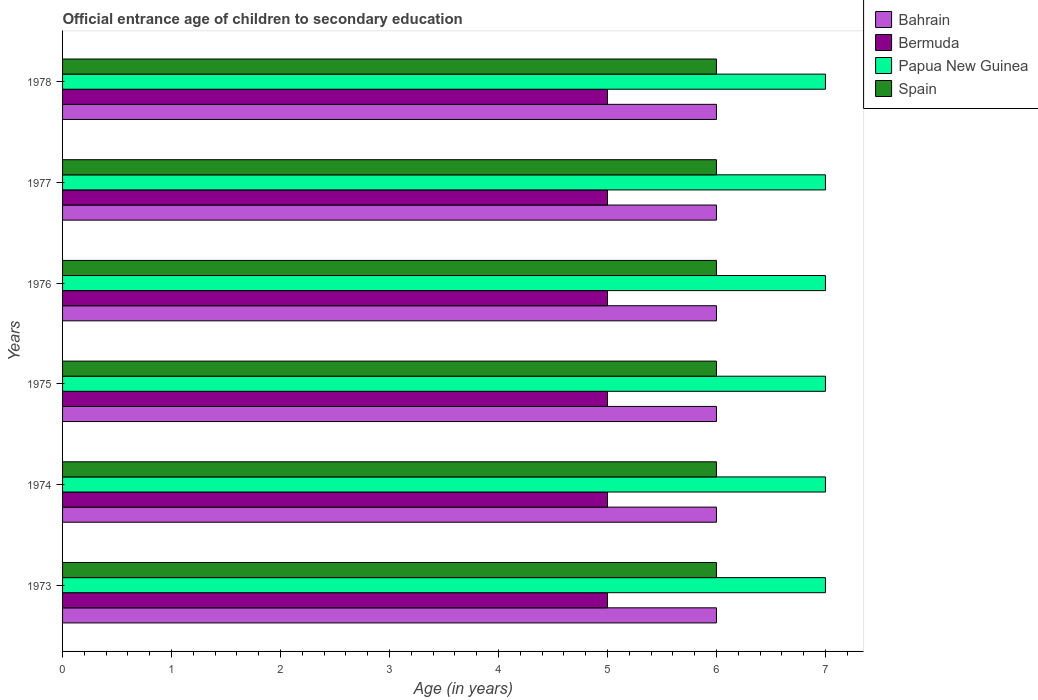How many groups of bars are there?
Make the answer very short. 6. Are the number of bars per tick equal to the number of legend labels?
Keep it short and to the point. Yes. How many bars are there on the 2nd tick from the bottom?
Offer a very short reply. 4. What is the label of the 5th group of bars from the top?
Offer a terse response. 1974. What is the secondary school starting age of children in Bermuda in 1975?
Provide a succinct answer. 5. Across all years, what is the maximum secondary school starting age of children in Papua New Guinea?
Your response must be concise. 7. Across all years, what is the minimum secondary school starting age of children in Papua New Guinea?
Your response must be concise. 7. What is the total secondary school starting age of children in Bahrain in the graph?
Your answer should be very brief. 36. What is the difference between the secondary school starting age of children in Bermuda in 1978 and the secondary school starting age of children in Papua New Guinea in 1976?
Your answer should be very brief. -2. In the year 1978, what is the difference between the secondary school starting age of children in Papua New Guinea and secondary school starting age of children in Spain?
Your answer should be very brief. 1. What is the ratio of the secondary school starting age of children in Bahrain in 1973 to that in 1975?
Your answer should be very brief. 1. Is the secondary school starting age of children in Bahrain in 1975 less than that in 1976?
Offer a terse response. No. In how many years, is the secondary school starting age of children in Papua New Guinea greater than the average secondary school starting age of children in Papua New Guinea taken over all years?
Give a very brief answer. 0. What does the 4th bar from the top in 1973 represents?
Your response must be concise. Bahrain. What does the 3rd bar from the bottom in 1977 represents?
Provide a succinct answer. Papua New Guinea. How many bars are there?
Your answer should be compact. 24. How many years are there in the graph?
Keep it short and to the point. 6. Does the graph contain grids?
Offer a very short reply. No. How are the legend labels stacked?
Your answer should be compact. Vertical. What is the title of the graph?
Keep it short and to the point. Official entrance age of children to secondary education. Does "Andorra" appear as one of the legend labels in the graph?
Make the answer very short. No. What is the label or title of the X-axis?
Keep it short and to the point. Age (in years). What is the Age (in years) of Bermuda in 1973?
Give a very brief answer. 5. What is the Age (in years) of Spain in 1974?
Your answer should be very brief. 6. What is the Age (in years) in Bahrain in 1975?
Provide a succinct answer. 6. What is the Age (in years) in Bermuda in 1975?
Offer a terse response. 5. What is the Age (in years) in Papua New Guinea in 1975?
Make the answer very short. 7. What is the Age (in years) of Bahrain in 1976?
Give a very brief answer. 6. What is the Age (in years) in Bermuda in 1976?
Keep it short and to the point. 5. What is the Age (in years) in Spain in 1977?
Keep it short and to the point. 6. What is the Age (in years) in Bahrain in 1978?
Ensure brevity in your answer.  6. What is the Age (in years) in Bermuda in 1978?
Offer a very short reply. 5. What is the Age (in years) in Spain in 1978?
Offer a terse response. 6. Across all years, what is the maximum Age (in years) of Papua New Guinea?
Your answer should be compact. 7. Across all years, what is the maximum Age (in years) in Spain?
Offer a very short reply. 6. Across all years, what is the minimum Age (in years) of Bahrain?
Give a very brief answer. 6. What is the total Age (in years) of Spain in the graph?
Provide a succinct answer. 36. What is the difference between the Age (in years) of Bahrain in 1973 and that in 1974?
Give a very brief answer. 0. What is the difference between the Age (in years) in Papua New Guinea in 1973 and that in 1974?
Offer a terse response. 0. What is the difference between the Age (in years) in Bahrain in 1973 and that in 1975?
Your answer should be compact. 0. What is the difference between the Age (in years) of Bermuda in 1973 and that in 1975?
Your answer should be compact. 0. What is the difference between the Age (in years) in Spain in 1973 and that in 1975?
Provide a short and direct response. 0. What is the difference between the Age (in years) in Bahrain in 1973 and that in 1976?
Provide a succinct answer. 0. What is the difference between the Age (in years) of Papua New Guinea in 1973 and that in 1976?
Provide a succinct answer. 0. What is the difference between the Age (in years) of Spain in 1973 and that in 1976?
Make the answer very short. 0. What is the difference between the Age (in years) of Bahrain in 1973 and that in 1977?
Provide a succinct answer. 0. What is the difference between the Age (in years) in Papua New Guinea in 1973 and that in 1978?
Make the answer very short. 0. What is the difference between the Age (in years) in Spain in 1973 and that in 1978?
Provide a short and direct response. 0. What is the difference between the Age (in years) in Bahrain in 1974 and that in 1975?
Your answer should be very brief. 0. What is the difference between the Age (in years) of Papua New Guinea in 1974 and that in 1975?
Make the answer very short. 0. What is the difference between the Age (in years) of Bahrain in 1974 and that in 1976?
Offer a terse response. 0. What is the difference between the Age (in years) of Bermuda in 1974 and that in 1976?
Your response must be concise. 0. What is the difference between the Age (in years) in Papua New Guinea in 1974 and that in 1976?
Keep it short and to the point. 0. What is the difference between the Age (in years) of Spain in 1974 and that in 1976?
Your response must be concise. 0. What is the difference between the Age (in years) in Bahrain in 1974 and that in 1977?
Provide a short and direct response. 0. What is the difference between the Age (in years) of Bermuda in 1974 and that in 1977?
Make the answer very short. 0. What is the difference between the Age (in years) of Spain in 1974 and that in 1978?
Keep it short and to the point. 0. What is the difference between the Age (in years) in Bahrain in 1975 and that in 1976?
Your answer should be very brief. 0. What is the difference between the Age (in years) in Bermuda in 1975 and that in 1976?
Your answer should be compact. 0. What is the difference between the Age (in years) in Spain in 1975 and that in 1976?
Your answer should be compact. 0. What is the difference between the Age (in years) in Bahrain in 1975 and that in 1977?
Ensure brevity in your answer.  0. What is the difference between the Age (in years) in Bermuda in 1975 and that in 1977?
Your answer should be very brief. 0. What is the difference between the Age (in years) of Papua New Guinea in 1975 and that in 1977?
Make the answer very short. 0. What is the difference between the Age (in years) in Spain in 1975 and that in 1977?
Provide a succinct answer. 0. What is the difference between the Age (in years) of Bahrain in 1975 and that in 1978?
Give a very brief answer. 0. What is the difference between the Age (in years) in Bermuda in 1975 and that in 1978?
Provide a succinct answer. 0. What is the difference between the Age (in years) in Papua New Guinea in 1975 and that in 1978?
Your answer should be compact. 0. What is the difference between the Age (in years) in Spain in 1976 and that in 1977?
Offer a terse response. 0. What is the difference between the Age (in years) of Bahrain in 1976 and that in 1978?
Offer a terse response. 0. What is the difference between the Age (in years) of Papua New Guinea in 1976 and that in 1978?
Make the answer very short. 0. What is the difference between the Age (in years) in Bahrain in 1977 and that in 1978?
Provide a succinct answer. 0. What is the difference between the Age (in years) in Papua New Guinea in 1977 and that in 1978?
Your answer should be very brief. 0. What is the difference between the Age (in years) in Spain in 1977 and that in 1978?
Ensure brevity in your answer.  0. What is the difference between the Age (in years) of Bahrain in 1973 and the Age (in years) of Bermuda in 1974?
Your answer should be compact. 1. What is the difference between the Age (in years) in Papua New Guinea in 1973 and the Age (in years) in Spain in 1974?
Provide a succinct answer. 1. What is the difference between the Age (in years) of Bahrain in 1973 and the Age (in years) of Papua New Guinea in 1975?
Give a very brief answer. -1. What is the difference between the Age (in years) of Bahrain in 1973 and the Age (in years) of Spain in 1975?
Your answer should be very brief. 0. What is the difference between the Age (in years) of Bermuda in 1973 and the Age (in years) of Spain in 1975?
Keep it short and to the point. -1. What is the difference between the Age (in years) of Bahrain in 1973 and the Age (in years) of Bermuda in 1976?
Your answer should be compact. 1. What is the difference between the Age (in years) in Bermuda in 1973 and the Age (in years) in Spain in 1976?
Ensure brevity in your answer.  -1. What is the difference between the Age (in years) of Papua New Guinea in 1973 and the Age (in years) of Spain in 1976?
Offer a very short reply. 1. What is the difference between the Age (in years) of Bahrain in 1973 and the Age (in years) of Papua New Guinea in 1977?
Your response must be concise. -1. What is the difference between the Age (in years) in Bahrain in 1973 and the Age (in years) in Spain in 1977?
Ensure brevity in your answer.  0. What is the difference between the Age (in years) in Bermuda in 1973 and the Age (in years) in Spain in 1977?
Provide a succinct answer. -1. What is the difference between the Age (in years) in Bahrain in 1973 and the Age (in years) in Bermuda in 1978?
Offer a very short reply. 1. What is the difference between the Age (in years) of Bermuda in 1973 and the Age (in years) of Papua New Guinea in 1978?
Make the answer very short. -2. What is the difference between the Age (in years) in Bahrain in 1974 and the Age (in years) in Bermuda in 1975?
Make the answer very short. 1. What is the difference between the Age (in years) in Bahrain in 1974 and the Age (in years) in Papua New Guinea in 1975?
Ensure brevity in your answer.  -1. What is the difference between the Age (in years) of Bahrain in 1974 and the Age (in years) of Spain in 1975?
Provide a short and direct response. 0. What is the difference between the Age (in years) of Bermuda in 1974 and the Age (in years) of Papua New Guinea in 1975?
Make the answer very short. -2. What is the difference between the Age (in years) of Papua New Guinea in 1974 and the Age (in years) of Spain in 1975?
Your response must be concise. 1. What is the difference between the Age (in years) in Bahrain in 1974 and the Age (in years) in Bermuda in 1976?
Your answer should be very brief. 1. What is the difference between the Age (in years) of Bahrain in 1974 and the Age (in years) of Spain in 1976?
Your answer should be compact. 0. What is the difference between the Age (in years) of Bermuda in 1974 and the Age (in years) of Spain in 1976?
Give a very brief answer. -1. What is the difference between the Age (in years) in Papua New Guinea in 1974 and the Age (in years) in Spain in 1976?
Give a very brief answer. 1. What is the difference between the Age (in years) of Bahrain in 1974 and the Age (in years) of Papua New Guinea in 1977?
Offer a terse response. -1. What is the difference between the Age (in years) of Bahrain in 1974 and the Age (in years) of Spain in 1977?
Offer a terse response. 0. What is the difference between the Age (in years) in Papua New Guinea in 1974 and the Age (in years) in Spain in 1977?
Provide a short and direct response. 1. What is the difference between the Age (in years) of Bermuda in 1974 and the Age (in years) of Papua New Guinea in 1978?
Give a very brief answer. -2. What is the difference between the Age (in years) in Bahrain in 1975 and the Age (in years) in Papua New Guinea in 1976?
Make the answer very short. -1. What is the difference between the Age (in years) of Bermuda in 1975 and the Age (in years) of Papua New Guinea in 1976?
Offer a terse response. -2. What is the difference between the Age (in years) in Papua New Guinea in 1975 and the Age (in years) in Spain in 1976?
Offer a very short reply. 1. What is the difference between the Age (in years) of Bahrain in 1975 and the Age (in years) of Papua New Guinea in 1977?
Make the answer very short. -1. What is the difference between the Age (in years) of Bahrain in 1975 and the Age (in years) of Spain in 1978?
Make the answer very short. 0. What is the difference between the Age (in years) of Papua New Guinea in 1975 and the Age (in years) of Spain in 1978?
Provide a succinct answer. 1. What is the difference between the Age (in years) in Bahrain in 1976 and the Age (in years) in Papua New Guinea in 1977?
Offer a very short reply. -1. What is the difference between the Age (in years) of Bermuda in 1976 and the Age (in years) of Spain in 1977?
Offer a very short reply. -1. What is the difference between the Age (in years) in Bahrain in 1976 and the Age (in years) in Papua New Guinea in 1978?
Keep it short and to the point. -1. What is the difference between the Age (in years) in Bahrain in 1976 and the Age (in years) in Spain in 1978?
Ensure brevity in your answer.  0. What is the difference between the Age (in years) of Bermuda in 1976 and the Age (in years) of Papua New Guinea in 1978?
Give a very brief answer. -2. What is the difference between the Age (in years) in Papua New Guinea in 1976 and the Age (in years) in Spain in 1978?
Offer a very short reply. 1. What is the difference between the Age (in years) in Bahrain in 1977 and the Age (in years) in Bermuda in 1978?
Your answer should be very brief. 1. What is the difference between the Age (in years) of Bahrain in 1977 and the Age (in years) of Papua New Guinea in 1978?
Your answer should be very brief. -1. What is the difference between the Age (in years) of Bermuda in 1977 and the Age (in years) of Papua New Guinea in 1978?
Offer a terse response. -2. What is the difference between the Age (in years) in Papua New Guinea in 1977 and the Age (in years) in Spain in 1978?
Offer a very short reply. 1. What is the average Age (in years) of Bahrain per year?
Offer a very short reply. 6. What is the average Age (in years) of Bermuda per year?
Provide a short and direct response. 5. What is the average Age (in years) in Papua New Guinea per year?
Provide a succinct answer. 7. What is the average Age (in years) of Spain per year?
Give a very brief answer. 6. In the year 1973, what is the difference between the Age (in years) of Bahrain and Age (in years) of Bermuda?
Give a very brief answer. 1. In the year 1973, what is the difference between the Age (in years) in Bahrain and Age (in years) in Papua New Guinea?
Keep it short and to the point. -1. In the year 1973, what is the difference between the Age (in years) of Bahrain and Age (in years) of Spain?
Your response must be concise. 0. In the year 1973, what is the difference between the Age (in years) in Bermuda and Age (in years) in Papua New Guinea?
Make the answer very short. -2. In the year 1973, what is the difference between the Age (in years) of Bermuda and Age (in years) of Spain?
Provide a short and direct response. -1. In the year 1973, what is the difference between the Age (in years) in Papua New Guinea and Age (in years) in Spain?
Your answer should be compact. 1. In the year 1974, what is the difference between the Age (in years) in Bahrain and Age (in years) in Spain?
Provide a short and direct response. 0. In the year 1974, what is the difference between the Age (in years) of Bermuda and Age (in years) of Spain?
Your response must be concise. -1. In the year 1975, what is the difference between the Age (in years) of Bahrain and Age (in years) of Spain?
Offer a very short reply. 0. In the year 1975, what is the difference between the Age (in years) of Papua New Guinea and Age (in years) of Spain?
Your response must be concise. 1. In the year 1976, what is the difference between the Age (in years) in Bahrain and Age (in years) in Bermuda?
Your answer should be compact. 1. In the year 1976, what is the difference between the Age (in years) of Bahrain and Age (in years) of Papua New Guinea?
Give a very brief answer. -1. In the year 1976, what is the difference between the Age (in years) in Bermuda and Age (in years) in Papua New Guinea?
Provide a short and direct response. -2. In the year 1976, what is the difference between the Age (in years) in Bermuda and Age (in years) in Spain?
Your answer should be very brief. -1. In the year 1977, what is the difference between the Age (in years) of Bahrain and Age (in years) of Bermuda?
Offer a terse response. 1. In the year 1977, what is the difference between the Age (in years) in Bahrain and Age (in years) in Papua New Guinea?
Your answer should be very brief. -1. In the year 1977, what is the difference between the Age (in years) in Bahrain and Age (in years) in Spain?
Offer a terse response. 0. In the year 1977, what is the difference between the Age (in years) of Papua New Guinea and Age (in years) of Spain?
Your answer should be compact. 1. In the year 1978, what is the difference between the Age (in years) in Bahrain and Age (in years) in Bermuda?
Your answer should be compact. 1. In the year 1978, what is the difference between the Age (in years) of Bahrain and Age (in years) of Papua New Guinea?
Provide a succinct answer. -1. In the year 1978, what is the difference between the Age (in years) of Bermuda and Age (in years) of Spain?
Give a very brief answer. -1. What is the ratio of the Age (in years) in Papua New Guinea in 1973 to that in 1974?
Your answer should be compact. 1. What is the ratio of the Age (in years) in Spain in 1973 to that in 1974?
Your answer should be compact. 1. What is the ratio of the Age (in years) in Bahrain in 1973 to that in 1975?
Keep it short and to the point. 1. What is the ratio of the Age (in years) of Bermuda in 1973 to that in 1975?
Make the answer very short. 1. What is the ratio of the Age (in years) in Spain in 1973 to that in 1975?
Your answer should be compact. 1. What is the ratio of the Age (in years) in Papua New Guinea in 1973 to that in 1976?
Ensure brevity in your answer.  1. What is the ratio of the Age (in years) of Spain in 1973 to that in 1976?
Provide a short and direct response. 1. What is the ratio of the Age (in years) of Bermuda in 1973 to that in 1977?
Offer a terse response. 1. What is the ratio of the Age (in years) of Papua New Guinea in 1973 to that in 1977?
Ensure brevity in your answer.  1. What is the ratio of the Age (in years) in Bermuda in 1973 to that in 1978?
Keep it short and to the point. 1. What is the ratio of the Age (in years) of Spain in 1973 to that in 1978?
Ensure brevity in your answer.  1. What is the ratio of the Age (in years) in Bermuda in 1974 to that in 1975?
Ensure brevity in your answer.  1. What is the ratio of the Age (in years) of Spain in 1974 to that in 1975?
Give a very brief answer. 1. What is the ratio of the Age (in years) of Bahrain in 1974 to that in 1976?
Your response must be concise. 1. What is the ratio of the Age (in years) in Bahrain in 1974 to that in 1977?
Keep it short and to the point. 1. What is the ratio of the Age (in years) in Bermuda in 1974 to that in 1977?
Your answer should be compact. 1. What is the ratio of the Age (in years) of Bahrain in 1974 to that in 1978?
Offer a very short reply. 1. What is the ratio of the Age (in years) of Papua New Guinea in 1974 to that in 1978?
Provide a succinct answer. 1. What is the ratio of the Age (in years) of Bermuda in 1975 to that in 1976?
Your answer should be compact. 1. What is the ratio of the Age (in years) in Bahrain in 1975 to that in 1977?
Your answer should be very brief. 1. What is the ratio of the Age (in years) in Papua New Guinea in 1975 to that in 1977?
Keep it short and to the point. 1. What is the ratio of the Age (in years) of Bahrain in 1975 to that in 1978?
Provide a succinct answer. 1. What is the ratio of the Age (in years) of Spain in 1975 to that in 1978?
Give a very brief answer. 1. What is the ratio of the Age (in years) in Bermuda in 1976 to that in 1977?
Offer a very short reply. 1. What is the ratio of the Age (in years) in Papua New Guinea in 1976 to that in 1977?
Your answer should be compact. 1. What is the ratio of the Age (in years) in Bahrain in 1976 to that in 1978?
Make the answer very short. 1. What is the ratio of the Age (in years) in Spain in 1976 to that in 1978?
Offer a terse response. 1. What is the ratio of the Age (in years) of Bermuda in 1977 to that in 1978?
Provide a succinct answer. 1. What is the ratio of the Age (in years) of Papua New Guinea in 1977 to that in 1978?
Your answer should be very brief. 1. What is the difference between the highest and the second highest Age (in years) in Papua New Guinea?
Your response must be concise. 0. What is the difference between the highest and the lowest Age (in years) of Bahrain?
Give a very brief answer. 0. What is the difference between the highest and the lowest Age (in years) in Bermuda?
Make the answer very short. 0. What is the difference between the highest and the lowest Age (in years) of Spain?
Keep it short and to the point. 0. 